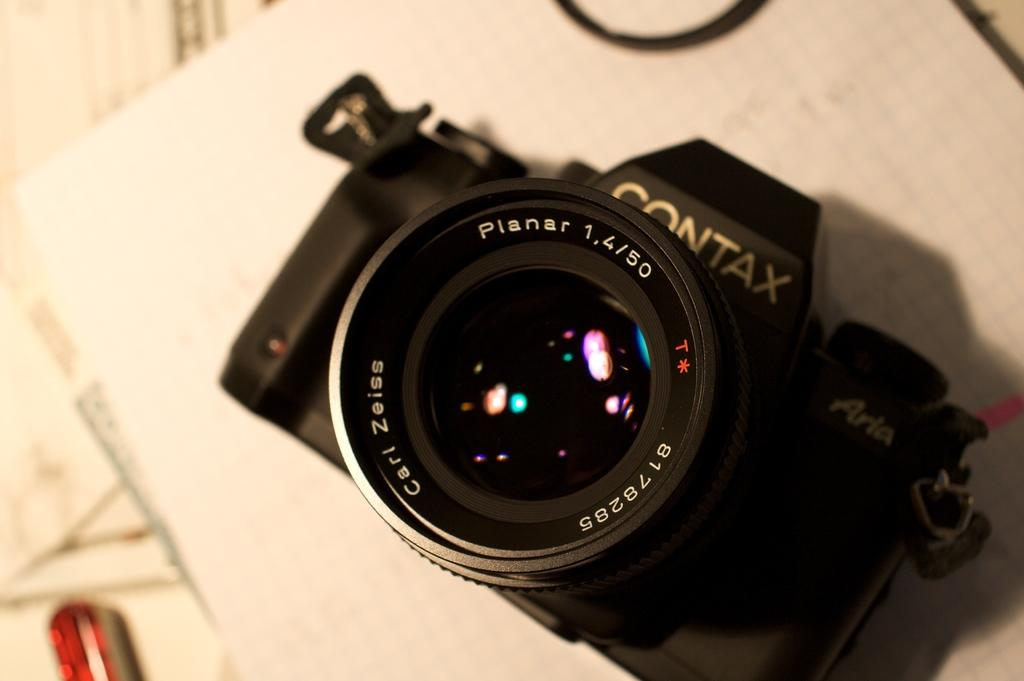What object is the main subject of the image? There is a camera in the image. What is the color of the camera? The camera is black in color. Where is the camera placed in the image? The camera is on a white surface. What type of line is visible on the camera in the image? There is no line visible on the camera in the image. What process is being performed on the camera in the image? There is no process being performed on the camera in the image; it is simply placed on a white surface. 